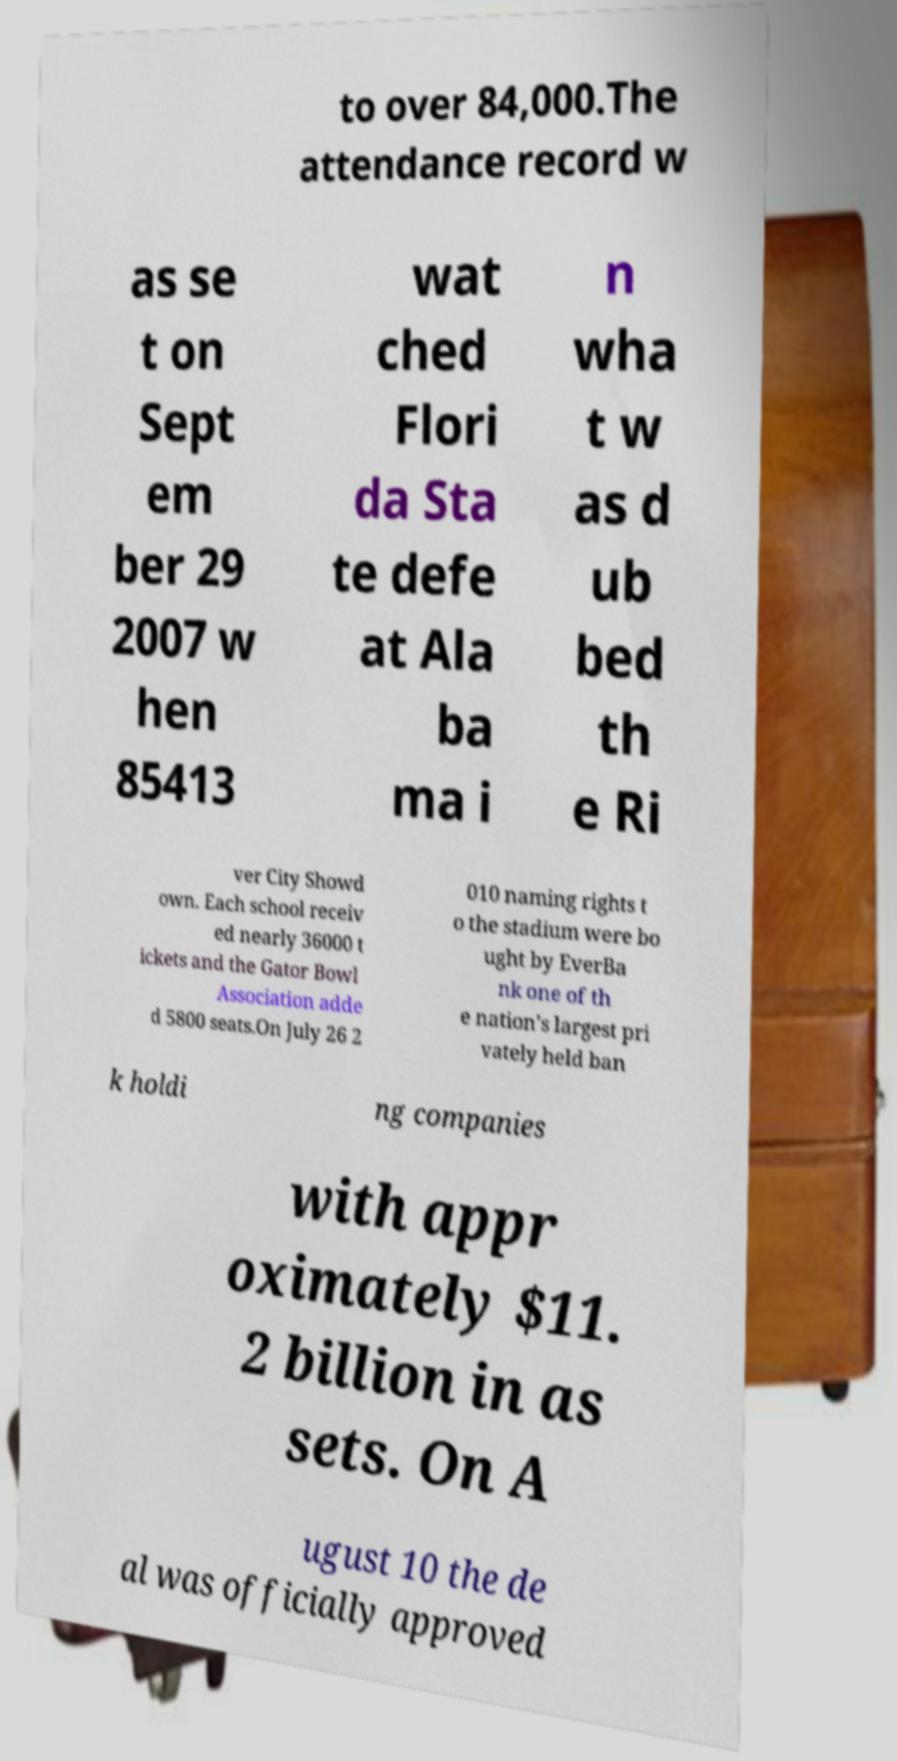Could you assist in decoding the text presented in this image and type it out clearly? to over 84,000.The attendance record w as se t on Sept em ber 29 2007 w hen 85413 wat ched Flori da Sta te defe at Ala ba ma i n wha t w as d ub bed th e Ri ver City Showd own. Each school receiv ed nearly 36000 t ickets and the Gator Bowl Association adde d 5800 seats.On July 26 2 010 naming rights t o the stadium were bo ught by EverBa nk one of th e nation's largest pri vately held ban k holdi ng companies with appr oximately $11. 2 billion in as sets. On A ugust 10 the de al was officially approved 